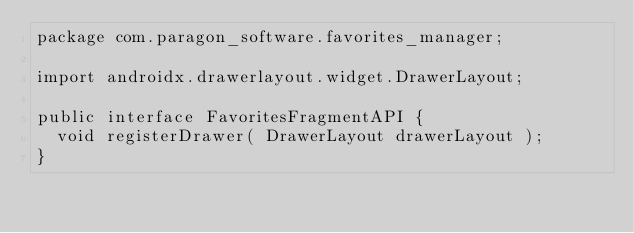<code> <loc_0><loc_0><loc_500><loc_500><_Java_>package com.paragon_software.favorites_manager;

import androidx.drawerlayout.widget.DrawerLayout;

public interface FavoritesFragmentAPI {
  void registerDrawer( DrawerLayout drawerLayout );
}
</code> 